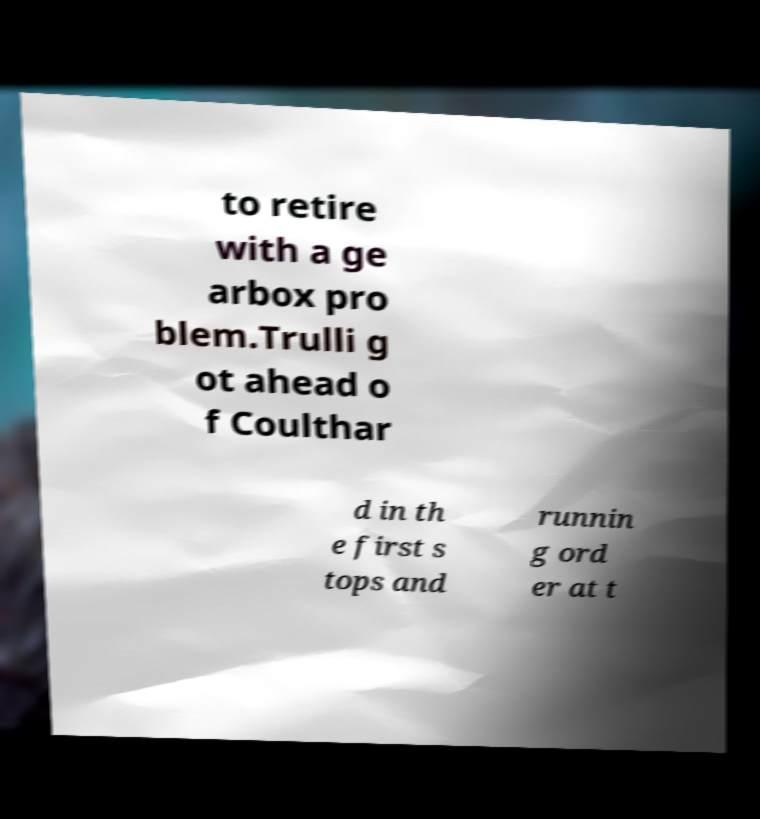For documentation purposes, I need the text within this image transcribed. Could you provide that? to retire with a ge arbox pro blem.Trulli g ot ahead o f Coulthar d in th e first s tops and runnin g ord er at t 